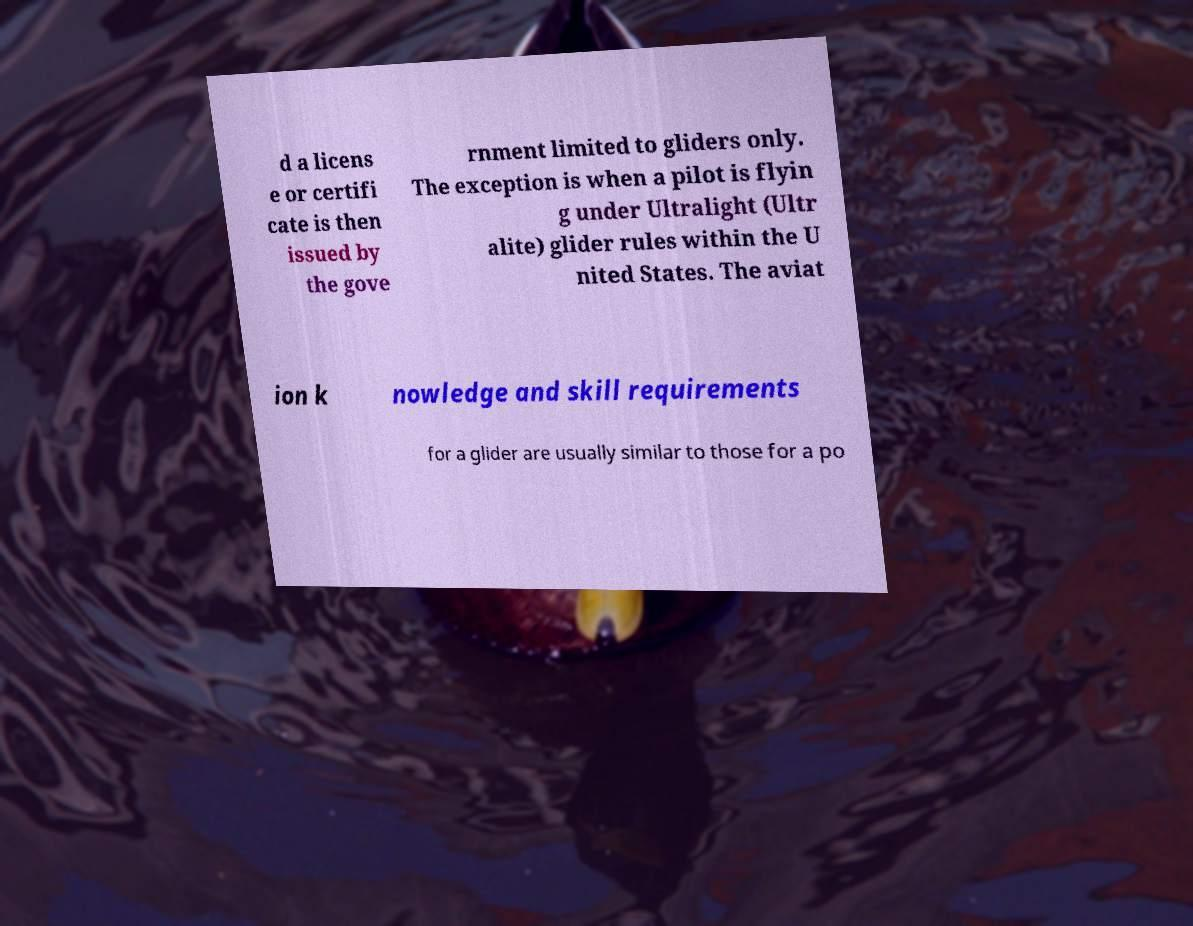There's text embedded in this image that I need extracted. Can you transcribe it verbatim? d a licens e or certifi cate is then issued by the gove rnment limited to gliders only. The exception is when a pilot is flyin g under Ultralight (Ultr alite) glider rules within the U nited States. The aviat ion k nowledge and skill requirements for a glider are usually similar to those for a po 